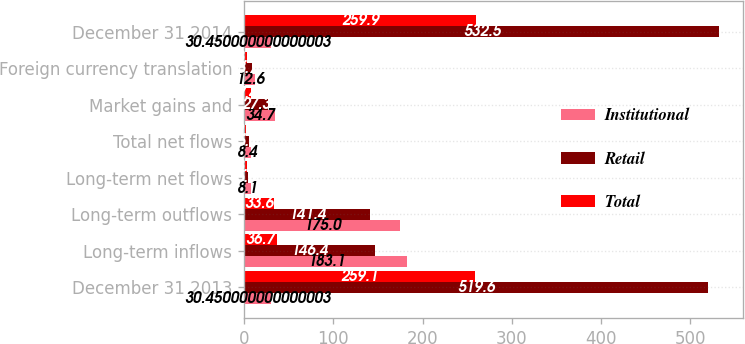<chart> <loc_0><loc_0><loc_500><loc_500><stacked_bar_chart><ecel><fcel>December 31 2013<fcel>Long-term inflows<fcel>Long-term outflows<fcel>Long-term net flows<fcel>Total net flows<fcel>Market gains and<fcel>Foreign currency translation<fcel>December 31 2014<nl><fcel>Institutional<fcel>30.45<fcel>183.1<fcel>175<fcel>8.1<fcel>8.4<fcel>34.7<fcel>12.6<fcel>30.45<nl><fcel>Retail<fcel>519.6<fcel>146.4<fcel>141.4<fcel>5<fcel>5.7<fcel>27.3<fcel>8.7<fcel>532.5<nl><fcel>Total<fcel>259.1<fcel>36.7<fcel>33.6<fcel>3.1<fcel>2.7<fcel>7.4<fcel>3.9<fcel>259.9<nl></chart> 